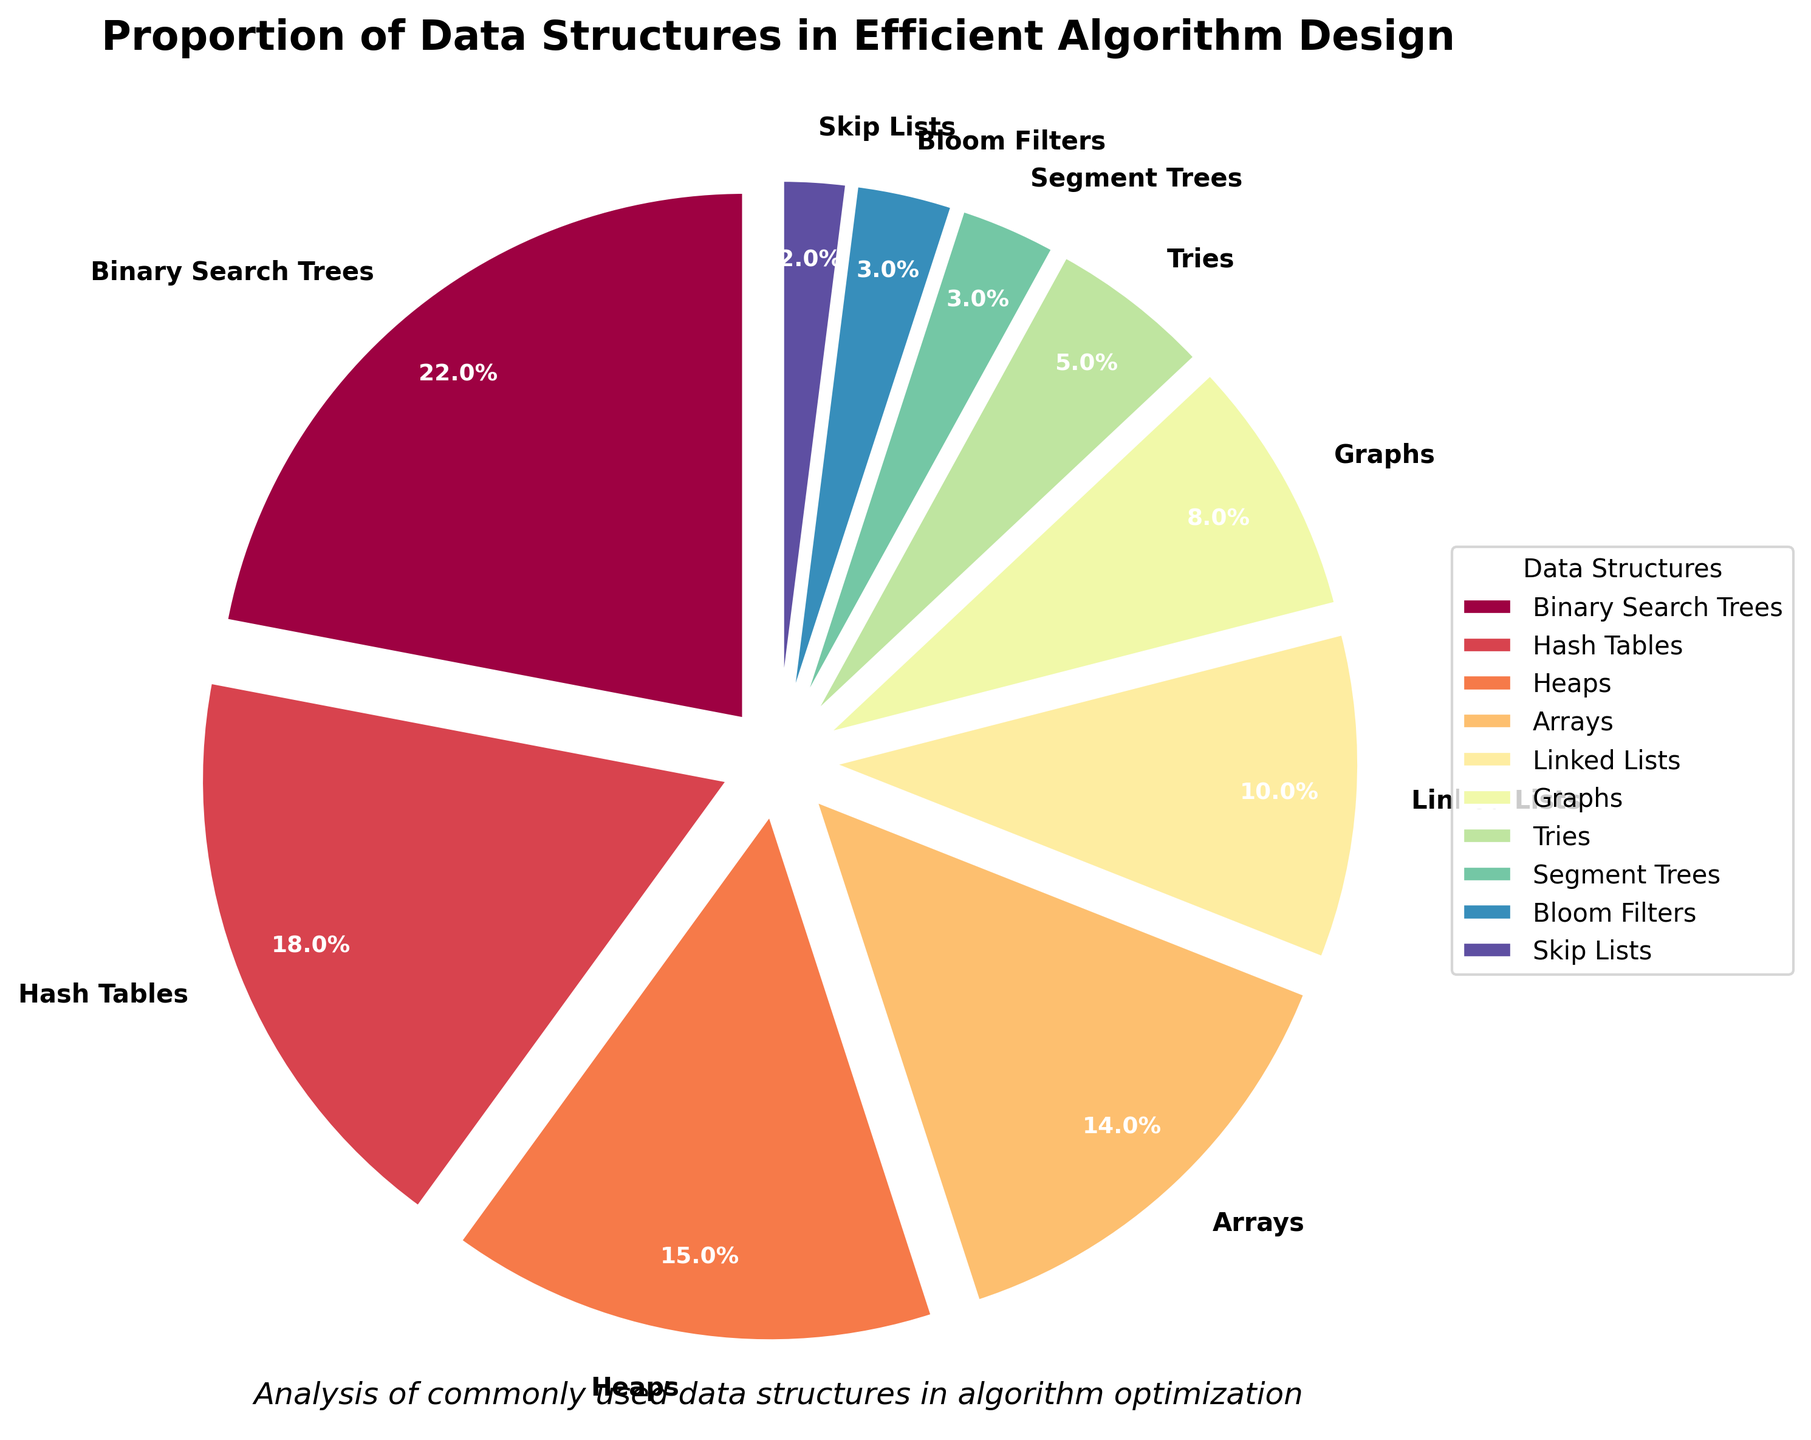Which data structure has the largest proportion? By looking at the pie chart, the largest wedge represents Binary Search Trees. The size and percentage label confirm it.
Answer: Binary Search Trees Which data structure has the smallest proportion? The smallest wedge, indicating the data structure, represents Skip Lists with a 2% proportion.
Answer: Skip Lists What is the combined proportion of Heaps and Arrays? Heaps have 15%, and Arrays have 14%. Adding these percentages gives 15 + 14 = 29%.
Answer: 29% Compare the proportions of Binary Search Trees and Hash Tables. Which one is larger and by how much? Binary Search Trees are 22%, and Hash Tables are 18%. The difference is 22 - 18 = 4%.
Answer: Binary Search Trees, by 4% How does the proportion of Linked Lists compare to the combined proportion of Segment Trees and Bloom Filters? Linked Lists have 10%, while Segment Trees and Bloom Filters have 3% each, making a combined total of 3 + 3 = 6%. Linked Lists are 10 - 6 = 4% larger.
Answer: Linked Lists, by 4% What data structures fall below a 10% usage proportion? Observing the pie chart, Graphs, Tries, Segment Trees, Bloom Filters, and Skip Lists each have proportions lower than 10%.
Answer: Graphs, Tries, Segment Trees, Bloom Filters, Skip Lists What is the proportion difference between the top two most used data structures? Binary Search Trees have 22%, and Hash Tables have 18%. The difference is 22 - 18 = 4%.
Answer: 4% If we combine the proportions of all data structures used less than 5%, what is the result? Segment Trees (3%), Bloom Filters (3%), and Skip Lists (2%) are each under 5%. Summing these gives 3 + 3 + 2 = 8%.
Answer: 8% Arrange the data structures in descending order of their usage proportions. Binary Search Trees (22%), Hash Tables (18%), Heaps (15%), Arrays (14%), Linked Lists (10%), Graphs (8%), Tries (5%), Segment Trees (3%), Bloom Filters (3%), Skip Lists (2%).
Answer: Binary Search Trees, Hash Tables, Heaps, Arrays, Linked Lists, Graphs, Tries, Segment Trees, Bloom Filters, Skip Lists What is the average usage proportion of Graphs, Tries, Segment Trees, and Bloom Filters? Their proportions are 8%, 5%, 3%, and 3% respectively. The sum of these percentages is 8 + 5 + 3 + 3 = 19%. The average is 19 / 4 = 4.75%.
Answer: 4.75% 